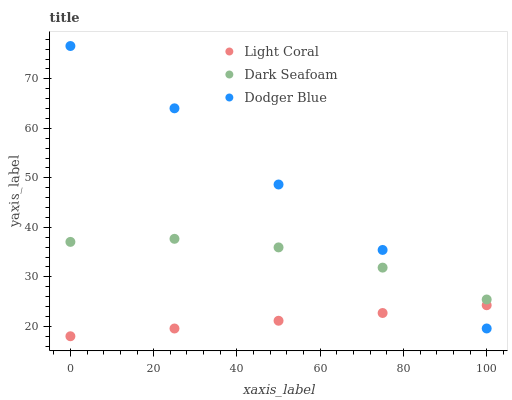Does Light Coral have the minimum area under the curve?
Answer yes or no. Yes. Does Dodger Blue have the maximum area under the curve?
Answer yes or no. Yes. Does Dark Seafoam have the minimum area under the curve?
Answer yes or no. No. Does Dark Seafoam have the maximum area under the curve?
Answer yes or no. No. Is Light Coral the smoothest?
Answer yes or no. Yes. Is Dodger Blue the roughest?
Answer yes or no. Yes. Is Dark Seafoam the smoothest?
Answer yes or no. No. Is Dark Seafoam the roughest?
Answer yes or no. No. Does Light Coral have the lowest value?
Answer yes or no. Yes. Does Dodger Blue have the lowest value?
Answer yes or no. No. Does Dodger Blue have the highest value?
Answer yes or no. Yes. Does Dark Seafoam have the highest value?
Answer yes or no. No. Is Light Coral less than Dark Seafoam?
Answer yes or no. Yes. Is Dark Seafoam greater than Light Coral?
Answer yes or no. Yes. Does Light Coral intersect Dodger Blue?
Answer yes or no. Yes. Is Light Coral less than Dodger Blue?
Answer yes or no. No. Is Light Coral greater than Dodger Blue?
Answer yes or no. No. Does Light Coral intersect Dark Seafoam?
Answer yes or no. No. 